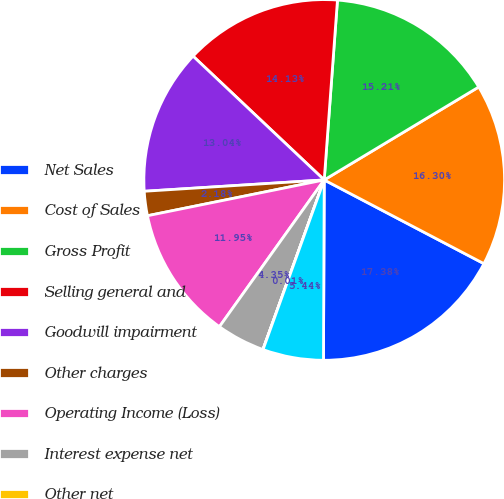Convert chart. <chart><loc_0><loc_0><loc_500><loc_500><pie_chart><fcel>Net Sales<fcel>Cost of Sales<fcel>Gross Profit<fcel>Selling general and<fcel>Goodwill impairment<fcel>Other charges<fcel>Operating Income (Loss)<fcel>Interest expense net<fcel>Other net<fcel>Equity in net earnings of<nl><fcel>17.38%<fcel>16.3%<fcel>15.21%<fcel>14.13%<fcel>13.04%<fcel>2.18%<fcel>11.95%<fcel>4.35%<fcel>0.01%<fcel>5.44%<nl></chart> 